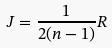<formula> <loc_0><loc_0><loc_500><loc_500>J = \frac { 1 } { 2 ( n - 1 ) } R</formula> 